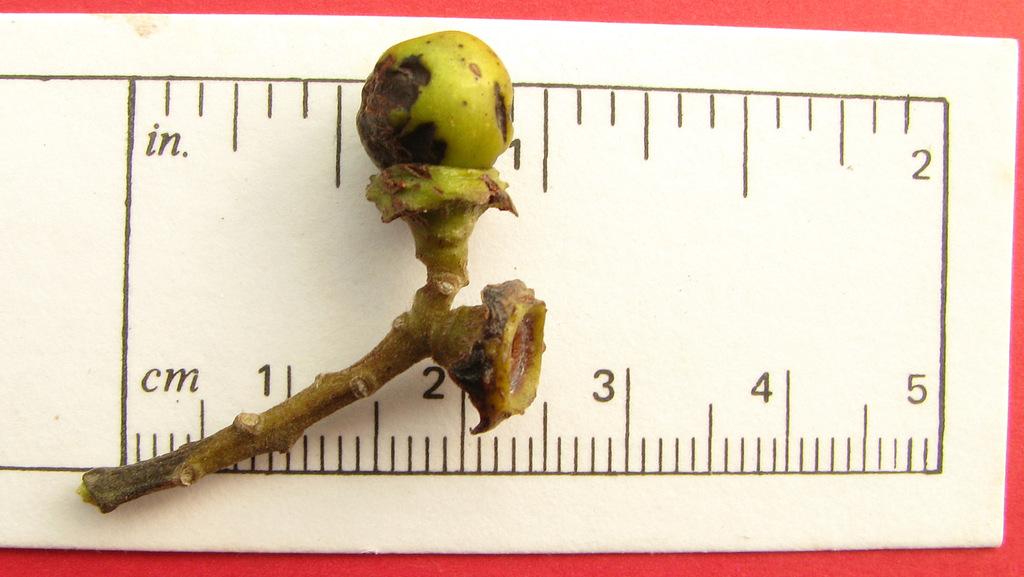How many centimeters is the branch?
Provide a succinct answer. 2.5. What is the max number that can be measured?
Your answer should be compact. 5. 